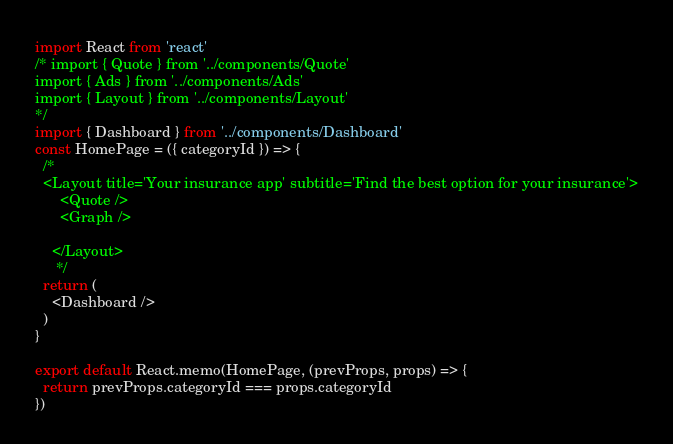Convert code to text. <code><loc_0><loc_0><loc_500><loc_500><_JavaScript_>import React from 'react'
/* import { Quote } from '../components/Quote'
import { Ads } from '../components/Ads'
import { Layout } from '../components/Layout'
*/
import { Dashboard } from '../components/Dashboard'
const HomePage = ({ categoryId }) => {
  /*
  <Layout title='Your insurance app' subtitle='Find the best option for your insurance'>
      <Quote />
      <Graph />

    </Layout>
     */
  return (
    <Dashboard />
  )
}

export default React.memo(HomePage, (prevProps, props) => {
  return prevProps.categoryId === props.categoryId
})
</code> 